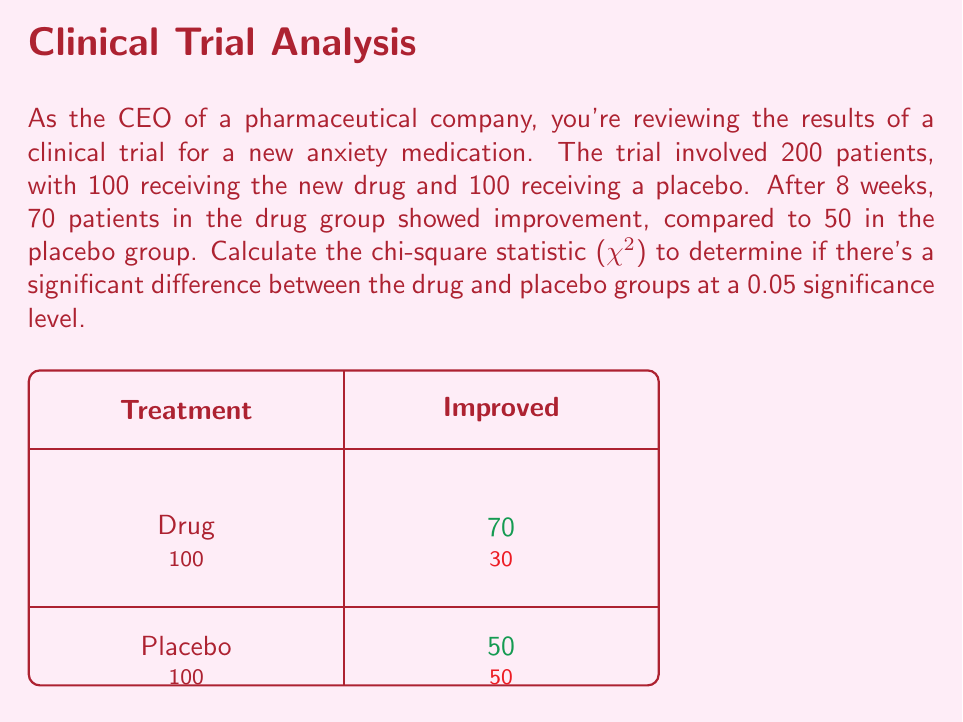Can you answer this question? To calculate the chi-square statistic, we'll follow these steps:

1) First, let's set up our contingency table:

   | Treatment | Improved | Not Improved | Total |
   |-----------|----------|--------------|-------|
   | Drug      | 70       | 30           | 100   |
   | Placebo   | 50       | 50           | 100   |
   | Total     | 120      | 80           | 200   |

2) The chi-square formula is:

   $$\chi^2 = \sum \frac{(O - E)^2}{E}$$

   where O is the observed frequency and E is the expected frequency.

3) Calculate the expected frequencies:
   
   For Drug-Improved: $E = \frac{100 \times 120}{200} = 60$
   For Drug-Not Improved: $E = \frac{100 \times 80}{200} = 40$
   For Placebo-Improved: $E = \frac{100 \times 120}{200} = 60$
   For Placebo-Not Improved: $E = \frac{100 \times 80}{200} = 40$

4) Now, let's calculate $(O - E)^2 / E$ for each cell:

   Drug-Improved: $\frac{(70 - 60)^2}{60} = 1.667$
   Drug-Not Improved: $\frac{(30 - 40)^2}{40} = 2.5$
   Placebo-Improved: $\frac{(50 - 60)^2}{60} = 1.667$
   Placebo-Not Improved: $\frac{(50 - 40)^2}{40} = 2.5$

5) Sum these values to get $\chi^2$:

   $\chi^2 = 1.667 + 2.5 + 1.667 + 2.5 = 8.334$

6) For a 2x2 contingency table, the degrees of freedom (df) = 1.

7) At a 0.05 significance level with 1 df, the critical value is 3.841.

8) Since our calculated $\chi^2$ (8.334) > critical value (3.841), we reject the null hypothesis.
Answer: $\chi^2 = 8.334$, statistically significant difference (p < 0.05) 